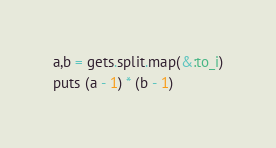Convert code to text. <code><loc_0><loc_0><loc_500><loc_500><_Ruby_>a,b = gets.split.map(&:to_i)
puts (a - 1) * (b - 1)</code> 